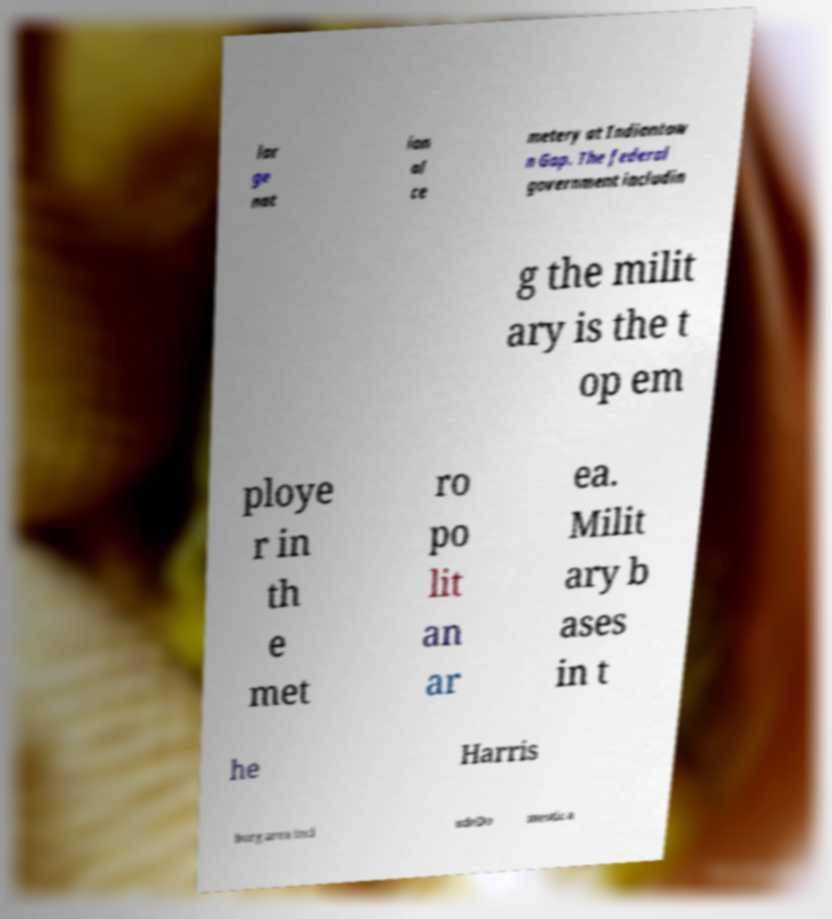I need the written content from this picture converted into text. Can you do that? lar ge nat ion al ce metery at Indiantow n Gap. The federal government includin g the milit ary is the t op em ploye r in th e met ro po lit an ar ea. Milit ary b ases in t he Harris burg area incl udeDo mestic a 